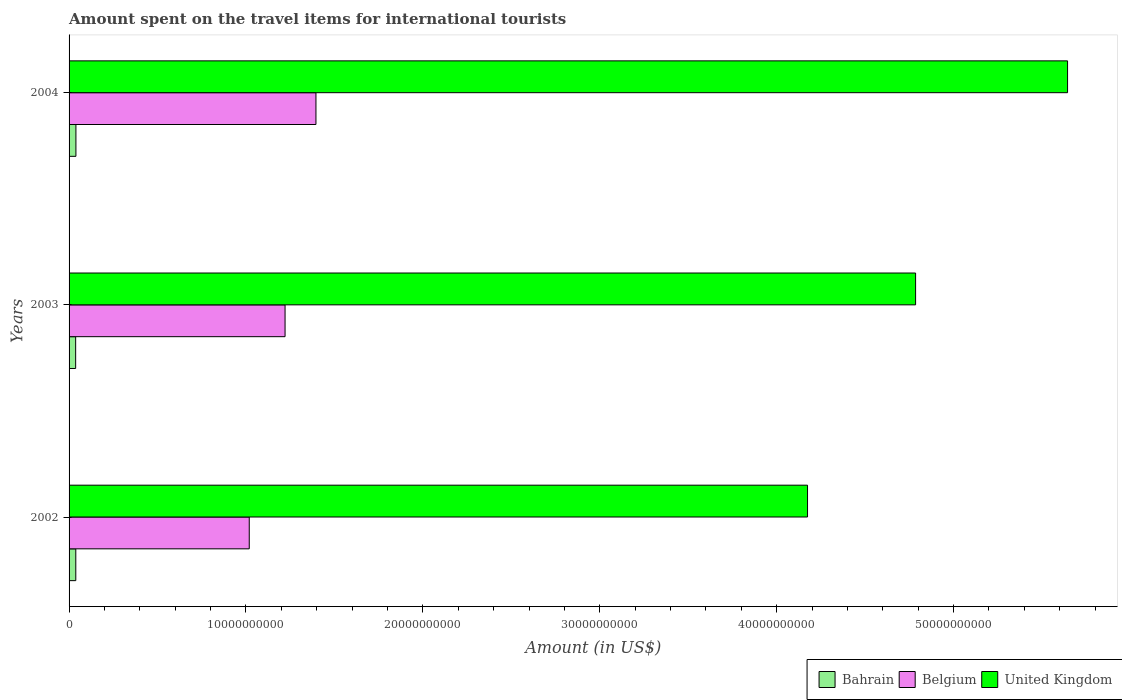How many different coloured bars are there?
Offer a very short reply. 3. In how many cases, is the number of bars for a given year not equal to the number of legend labels?
Make the answer very short. 0. What is the amount spent on the travel items for international tourists in United Kingdom in 2004?
Provide a short and direct response. 5.64e+1. Across all years, what is the maximum amount spent on the travel items for international tourists in Belgium?
Give a very brief answer. 1.40e+1. Across all years, what is the minimum amount spent on the travel items for international tourists in Belgium?
Your response must be concise. 1.02e+1. In which year was the amount spent on the travel items for international tourists in Bahrain maximum?
Offer a very short reply. 2004. In which year was the amount spent on the travel items for international tourists in United Kingdom minimum?
Your answer should be compact. 2002. What is the total amount spent on the travel items for international tourists in Bahrain in the graph?
Offer a terse response. 1.14e+09. What is the difference between the amount spent on the travel items for international tourists in Bahrain in 2002 and that in 2004?
Provide a succinct answer. -7.00e+06. What is the difference between the amount spent on the travel items for international tourists in Belgium in 2004 and the amount spent on the travel items for international tourists in Bahrain in 2003?
Provide a succinct answer. 1.36e+1. What is the average amount spent on the travel items for international tourists in Belgium per year?
Give a very brief answer. 1.21e+1. In the year 2003, what is the difference between the amount spent on the travel items for international tourists in United Kingdom and amount spent on the travel items for international tourists in Belgium?
Ensure brevity in your answer.  3.56e+1. What is the ratio of the amount spent on the travel items for international tourists in Bahrain in 2003 to that in 2004?
Offer a very short reply. 0.96. Is the difference between the amount spent on the travel items for international tourists in United Kingdom in 2003 and 2004 greater than the difference between the amount spent on the travel items for international tourists in Belgium in 2003 and 2004?
Your answer should be very brief. No. What is the difference between the highest and the lowest amount spent on the travel items for international tourists in Belgium?
Offer a very short reply. 3.77e+09. In how many years, is the amount spent on the travel items for international tourists in United Kingdom greater than the average amount spent on the travel items for international tourists in United Kingdom taken over all years?
Your answer should be very brief. 1. What does the 1st bar from the top in 2002 represents?
Your answer should be very brief. United Kingdom. How many bars are there?
Your response must be concise. 9. Are all the bars in the graph horizontal?
Your answer should be compact. Yes. Are the values on the major ticks of X-axis written in scientific E-notation?
Offer a terse response. No. Does the graph contain grids?
Your response must be concise. No. Where does the legend appear in the graph?
Make the answer very short. Bottom right. What is the title of the graph?
Your answer should be very brief. Amount spent on the travel items for international tourists. What is the Amount (in US$) in Bahrain in 2002?
Ensure brevity in your answer.  3.80e+08. What is the Amount (in US$) in Belgium in 2002?
Offer a terse response. 1.02e+1. What is the Amount (in US$) of United Kingdom in 2002?
Offer a very short reply. 4.17e+1. What is the Amount (in US$) in Bahrain in 2003?
Keep it short and to the point. 3.72e+08. What is the Amount (in US$) in Belgium in 2003?
Ensure brevity in your answer.  1.22e+1. What is the Amount (in US$) of United Kingdom in 2003?
Offer a very short reply. 4.79e+1. What is the Amount (in US$) of Bahrain in 2004?
Ensure brevity in your answer.  3.87e+08. What is the Amount (in US$) of Belgium in 2004?
Ensure brevity in your answer.  1.40e+1. What is the Amount (in US$) of United Kingdom in 2004?
Offer a very short reply. 5.64e+1. Across all years, what is the maximum Amount (in US$) of Bahrain?
Ensure brevity in your answer.  3.87e+08. Across all years, what is the maximum Amount (in US$) of Belgium?
Your answer should be compact. 1.40e+1. Across all years, what is the maximum Amount (in US$) of United Kingdom?
Your response must be concise. 5.64e+1. Across all years, what is the minimum Amount (in US$) in Bahrain?
Your answer should be very brief. 3.72e+08. Across all years, what is the minimum Amount (in US$) of Belgium?
Provide a short and direct response. 1.02e+1. Across all years, what is the minimum Amount (in US$) of United Kingdom?
Keep it short and to the point. 4.17e+1. What is the total Amount (in US$) in Bahrain in the graph?
Ensure brevity in your answer.  1.14e+09. What is the total Amount (in US$) in Belgium in the graph?
Ensure brevity in your answer.  3.64e+1. What is the total Amount (in US$) of United Kingdom in the graph?
Provide a succinct answer. 1.46e+11. What is the difference between the Amount (in US$) in Belgium in 2002 and that in 2003?
Make the answer very short. -2.02e+09. What is the difference between the Amount (in US$) of United Kingdom in 2002 and that in 2003?
Offer a terse response. -6.11e+09. What is the difference between the Amount (in US$) in Bahrain in 2002 and that in 2004?
Your response must be concise. -7.00e+06. What is the difference between the Amount (in US$) in Belgium in 2002 and that in 2004?
Provide a succinct answer. -3.77e+09. What is the difference between the Amount (in US$) of United Kingdom in 2002 and that in 2004?
Your answer should be compact. -1.47e+1. What is the difference between the Amount (in US$) of Bahrain in 2003 and that in 2004?
Offer a terse response. -1.50e+07. What is the difference between the Amount (in US$) of Belgium in 2003 and that in 2004?
Make the answer very short. -1.75e+09. What is the difference between the Amount (in US$) of United Kingdom in 2003 and that in 2004?
Give a very brief answer. -8.59e+09. What is the difference between the Amount (in US$) of Bahrain in 2002 and the Amount (in US$) of Belgium in 2003?
Provide a short and direct response. -1.18e+1. What is the difference between the Amount (in US$) of Bahrain in 2002 and the Amount (in US$) of United Kingdom in 2003?
Provide a short and direct response. -4.75e+1. What is the difference between the Amount (in US$) in Belgium in 2002 and the Amount (in US$) in United Kingdom in 2003?
Offer a terse response. -3.77e+1. What is the difference between the Amount (in US$) of Bahrain in 2002 and the Amount (in US$) of Belgium in 2004?
Ensure brevity in your answer.  -1.36e+1. What is the difference between the Amount (in US$) of Bahrain in 2002 and the Amount (in US$) of United Kingdom in 2004?
Ensure brevity in your answer.  -5.61e+1. What is the difference between the Amount (in US$) in Belgium in 2002 and the Amount (in US$) in United Kingdom in 2004?
Your response must be concise. -4.63e+1. What is the difference between the Amount (in US$) of Bahrain in 2003 and the Amount (in US$) of Belgium in 2004?
Your answer should be very brief. -1.36e+1. What is the difference between the Amount (in US$) in Bahrain in 2003 and the Amount (in US$) in United Kingdom in 2004?
Provide a succinct answer. -5.61e+1. What is the difference between the Amount (in US$) of Belgium in 2003 and the Amount (in US$) of United Kingdom in 2004?
Offer a terse response. -4.42e+1. What is the average Amount (in US$) in Bahrain per year?
Keep it short and to the point. 3.80e+08. What is the average Amount (in US$) of Belgium per year?
Your answer should be compact. 1.21e+1. What is the average Amount (in US$) of United Kingdom per year?
Ensure brevity in your answer.  4.87e+1. In the year 2002, what is the difference between the Amount (in US$) of Bahrain and Amount (in US$) of Belgium?
Ensure brevity in your answer.  -9.80e+09. In the year 2002, what is the difference between the Amount (in US$) of Bahrain and Amount (in US$) of United Kingdom?
Offer a very short reply. -4.14e+1. In the year 2002, what is the difference between the Amount (in US$) of Belgium and Amount (in US$) of United Kingdom?
Offer a very short reply. -3.16e+1. In the year 2003, what is the difference between the Amount (in US$) of Bahrain and Amount (in US$) of Belgium?
Ensure brevity in your answer.  -1.18e+1. In the year 2003, what is the difference between the Amount (in US$) of Bahrain and Amount (in US$) of United Kingdom?
Your answer should be compact. -4.75e+1. In the year 2003, what is the difference between the Amount (in US$) of Belgium and Amount (in US$) of United Kingdom?
Offer a terse response. -3.56e+1. In the year 2004, what is the difference between the Amount (in US$) of Bahrain and Amount (in US$) of Belgium?
Ensure brevity in your answer.  -1.36e+1. In the year 2004, what is the difference between the Amount (in US$) in Bahrain and Amount (in US$) in United Kingdom?
Your answer should be very brief. -5.61e+1. In the year 2004, what is the difference between the Amount (in US$) in Belgium and Amount (in US$) in United Kingdom?
Keep it short and to the point. -4.25e+1. What is the ratio of the Amount (in US$) of Bahrain in 2002 to that in 2003?
Offer a very short reply. 1.02. What is the ratio of the Amount (in US$) in Belgium in 2002 to that in 2003?
Give a very brief answer. 0.83. What is the ratio of the Amount (in US$) of United Kingdom in 2002 to that in 2003?
Provide a short and direct response. 0.87. What is the ratio of the Amount (in US$) of Bahrain in 2002 to that in 2004?
Offer a terse response. 0.98. What is the ratio of the Amount (in US$) of Belgium in 2002 to that in 2004?
Offer a terse response. 0.73. What is the ratio of the Amount (in US$) of United Kingdom in 2002 to that in 2004?
Offer a terse response. 0.74. What is the ratio of the Amount (in US$) of Bahrain in 2003 to that in 2004?
Offer a terse response. 0.96. What is the ratio of the Amount (in US$) of Belgium in 2003 to that in 2004?
Offer a terse response. 0.87. What is the ratio of the Amount (in US$) in United Kingdom in 2003 to that in 2004?
Provide a succinct answer. 0.85. What is the difference between the highest and the second highest Amount (in US$) in Belgium?
Give a very brief answer. 1.75e+09. What is the difference between the highest and the second highest Amount (in US$) in United Kingdom?
Your answer should be very brief. 8.59e+09. What is the difference between the highest and the lowest Amount (in US$) in Bahrain?
Provide a succinct answer. 1.50e+07. What is the difference between the highest and the lowest Amount (in US$) in Belgium?
Keep it short and to the point. 3.77e+09. What is the difference between the highest and the lowest Amount (in US$) in United Kingdom?
Your answer should be very brief. 1.47e+1. 